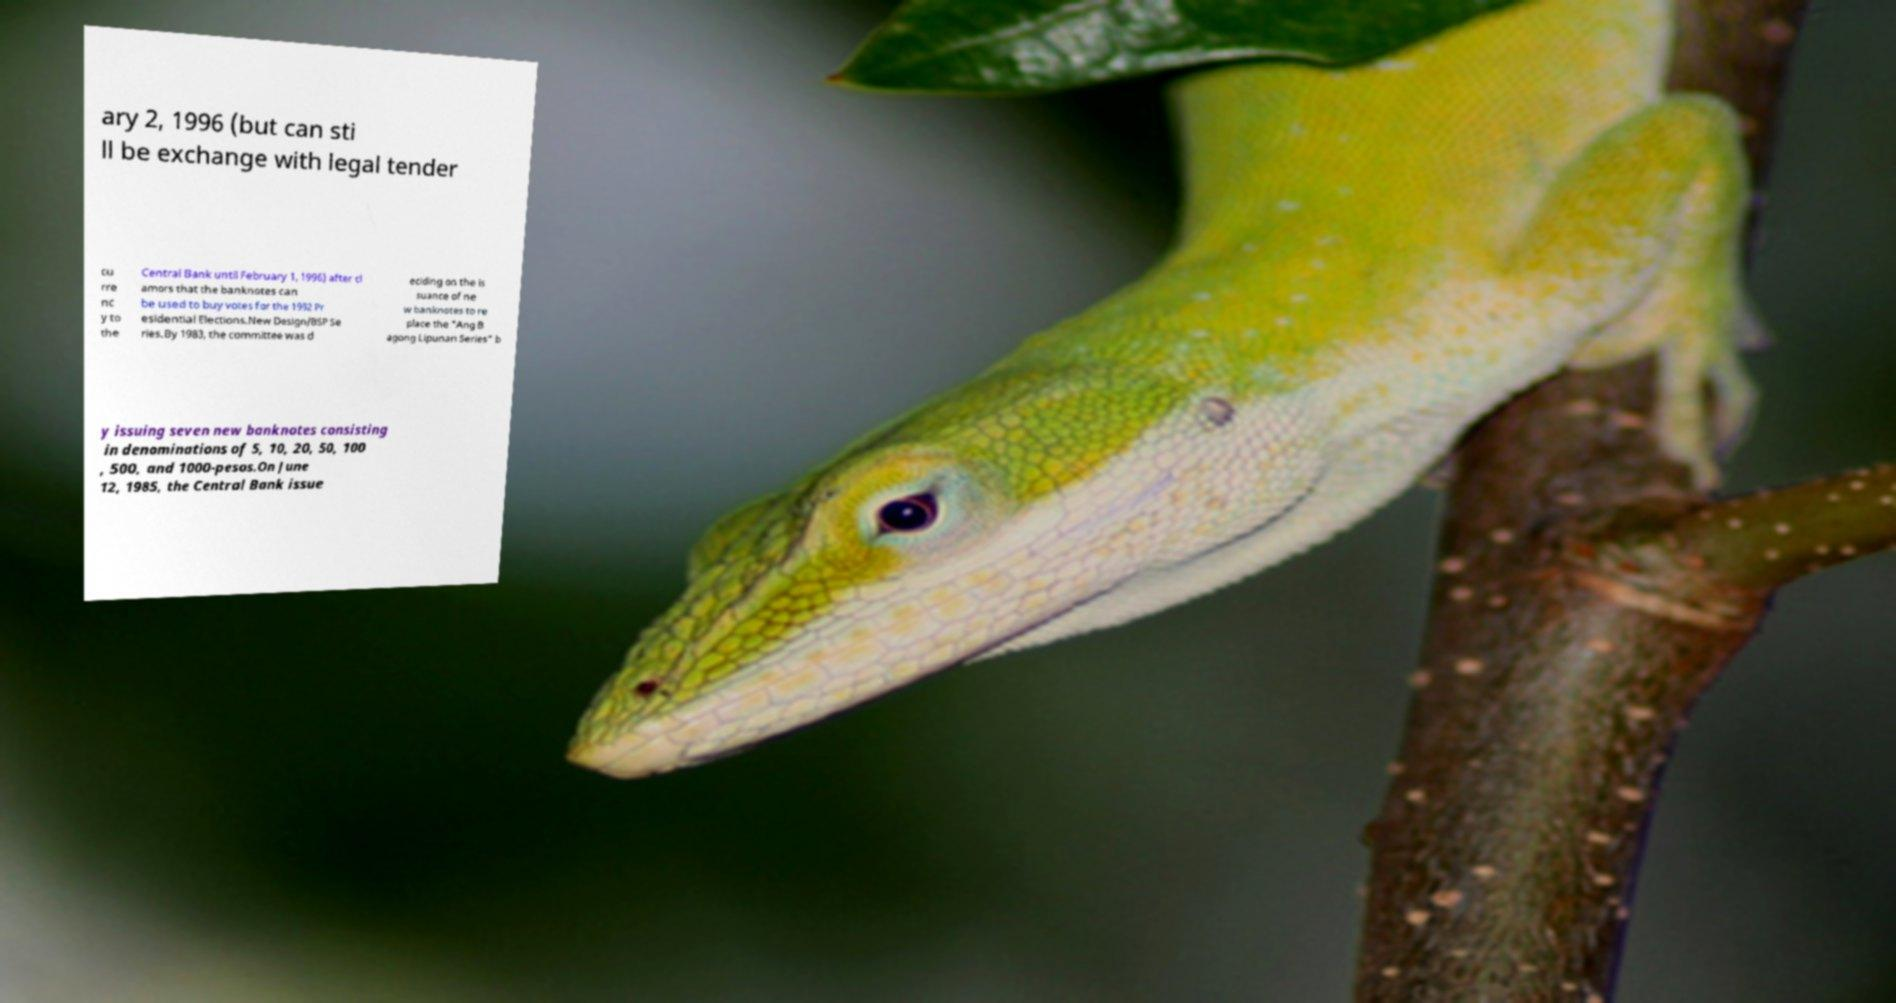Could you extract and type out the text from this image? ary 2, 1996 (but can sti ll be exchange with legal tender cu rre nc y to the Central Bank until February 1, 1996) after cl amors that the banknotes can be used to buy votes for the 1992 Pr esidential Elections.New Design/BSP Se ries.By 1983, the committee was d eciding on the is suance of ne w banknotes to re place the "Ang B agong Lipunan Series" b y issuing seven new banknotes consisting in denominations of 5, 10, 20, 50, 100 , 500, and 1000-pesos.On June 12, 1985, the Central Bank issue 